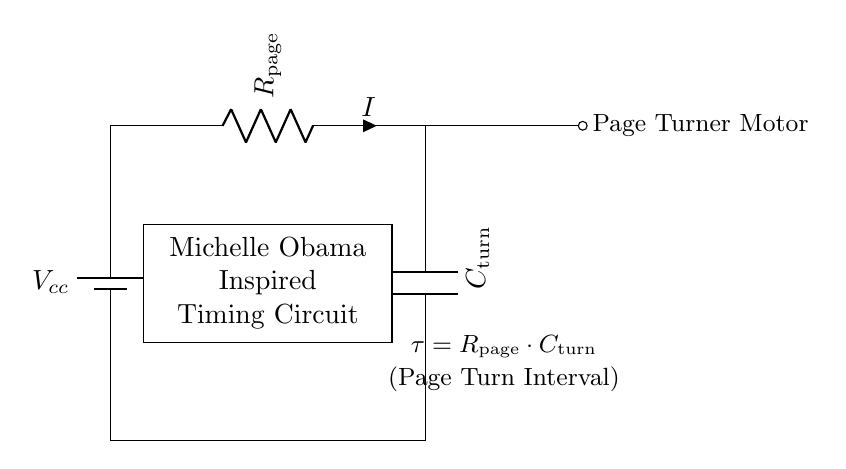What does R represent in the circuit? R represents the resistor labeled as "R page," which is used to limit the current in the timing circuit.
Answer: R page What is the function of C in the circuit? C represents the capacitor labeled as "C turn," which stores energy and contributes to the timing function for the page-turning device.
Answer: C turn What is the formula for calculating the time constant in this circuit? The formula for the time constant in this RC circuit is given as tau equals R page multiplied by C turn, indicating the time response of the timing circuit.
Answer: tau = R page * C turn What is the source of power in this circuit? The power source in this circuit is a battery, labeled as V cc, which provides the necessary voltage for operation.
Answer: V cc What component is connected to the capacitor? The component connected to the capacitor is a motor labeled as "Page Turner Motor," which is activated based on the timing circuit's output.
Answer: Page Turner Motor How does the current flow through the circuit? Current flows from the positive terminal of the battery, through the resistor, then through the capacitor and to the motor, completing the circuit loop.
Answer: From battery to resistor to capacitor to motor 